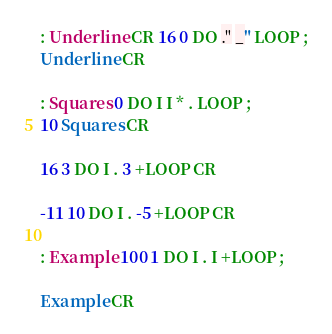Convert code to text. <code><loc_0><loc_0><loc_500><loc_500><_Forth_>: Underline CR 16 0 DO ." _" LOOP ;
Underline CR

: Squares 0 DO I I * . LOOP ;
10 Squares CR

16 3 DO I . 3 +LOOP CR

-11 10 DO I . -5 +LOOP CR

: Example 100 1 DO I . I +LOOP ;

Example CR
</code> 